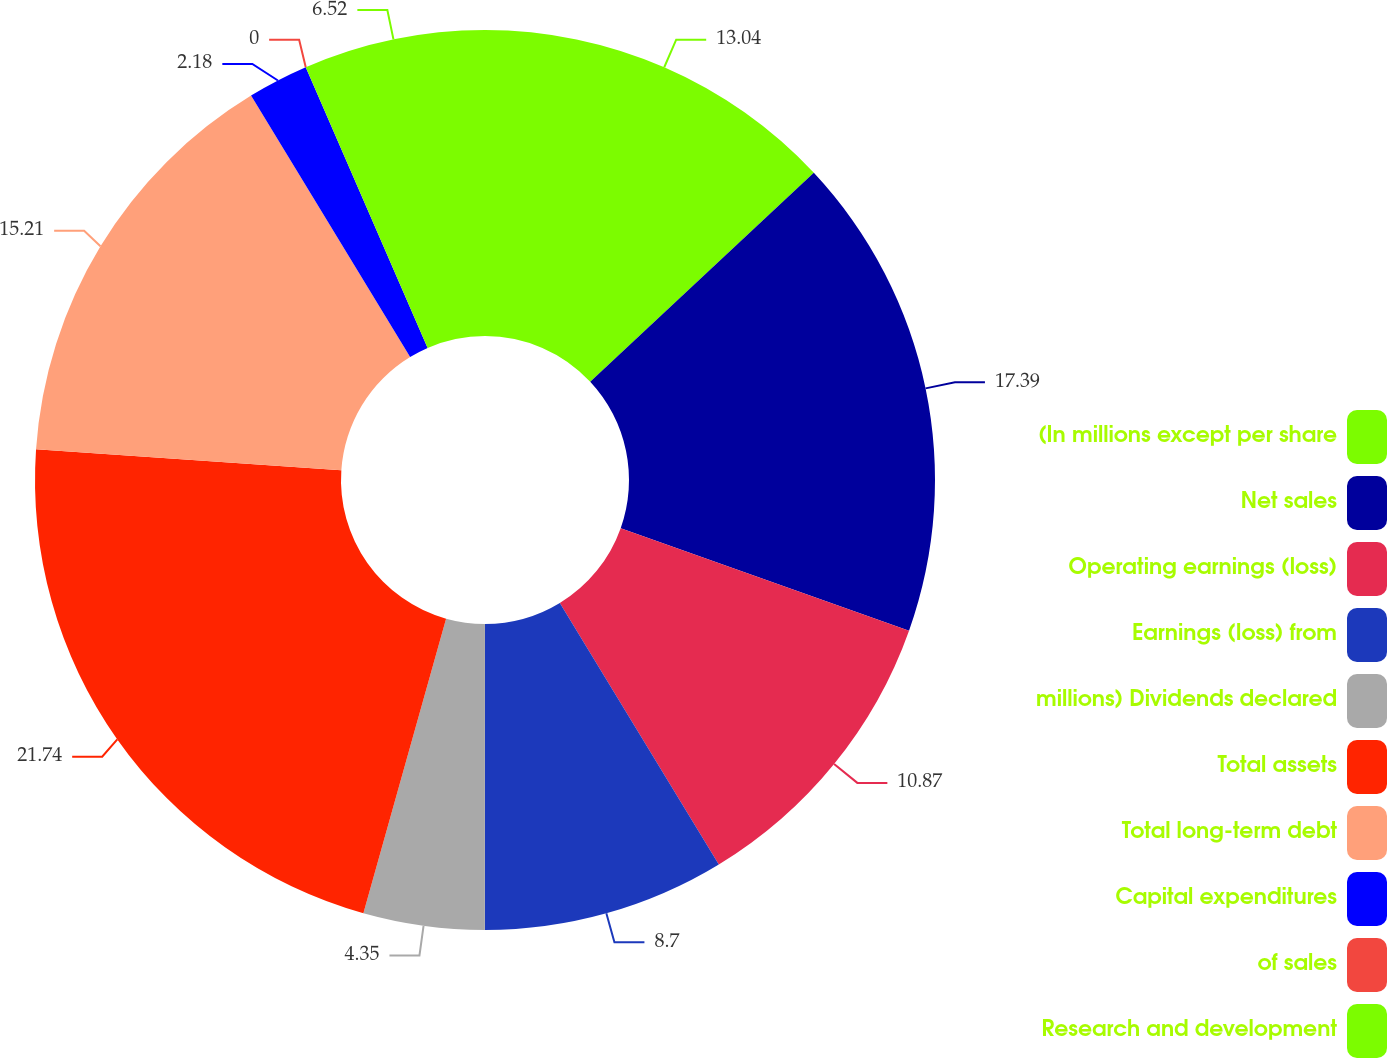Convert chart. <chart><loc_0><loc_0><loc_500><loc_500><pie_chart><fcel>(In millions except per share<fcel>Net sales<fcel>Operating earnings (loss)<fcel>Earnings (loss) from<fcel>millions) Dividends declared<fcel>Total assets<fcel>Total long-term debt<fcel>Capital expenditures<fcel>of sales<fcel>Research and development<nl><fcel>13.04%<fcel>17.39%<fcel>10.87%<fcel>8.7%<fcel>4.35%<fcel>21.73%<fcel>15.21%<fcel>2.18%<fcel>0.0%<fcel>6.52%<nl></chart> 